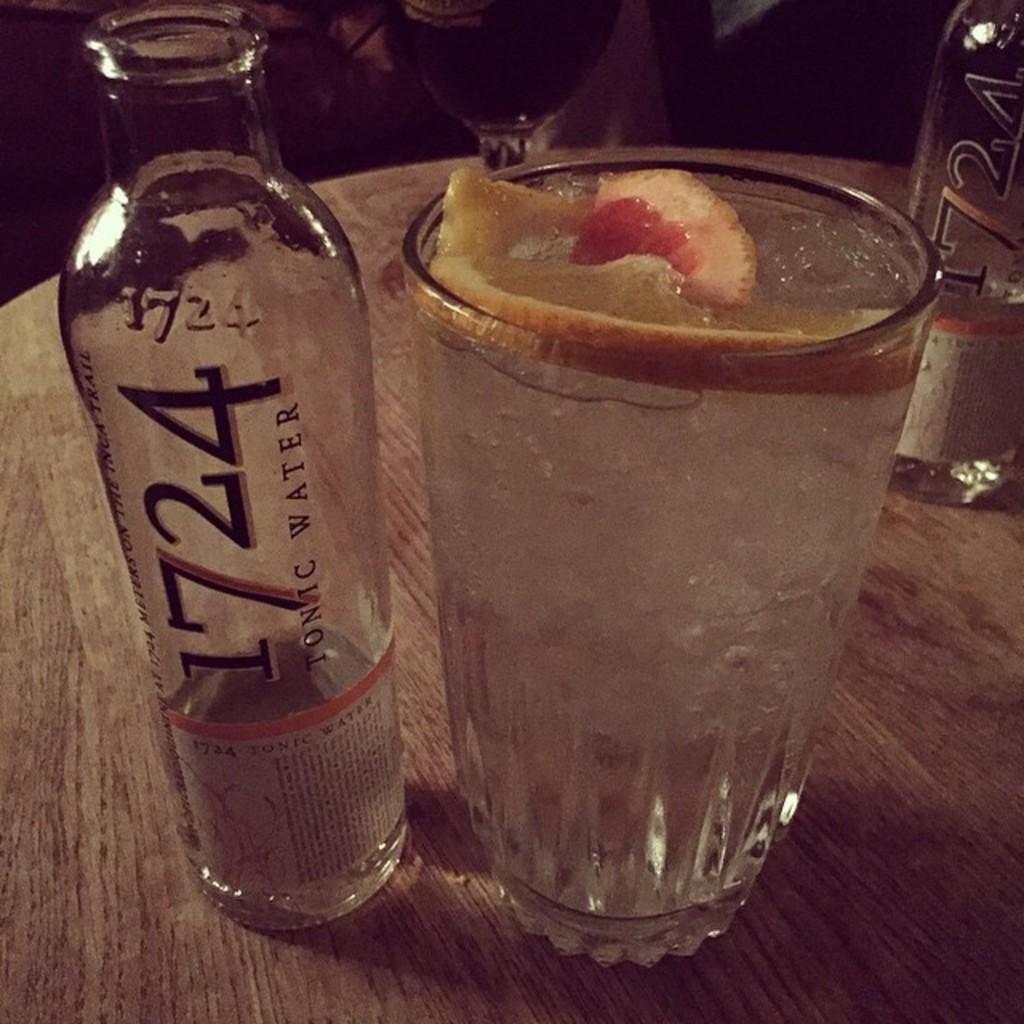Describe this image in one or two sentences. In this image I see 2 bottles and a glass, in which there is a fruit in it. 